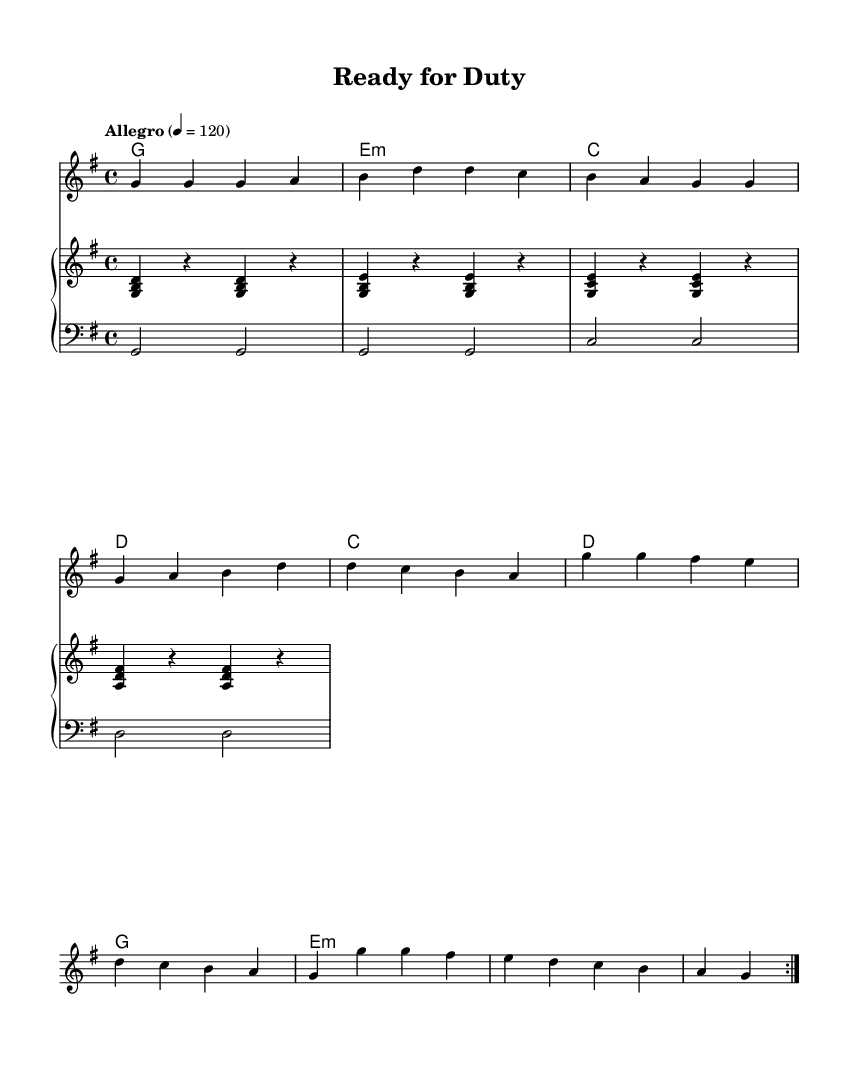What is the key signature of this music? The key signature indicates the music is in G major, which has one sharp (F#). This can be determined by looking at the key signature symbol, which shows one sharp at the top of the staff.
Answer: G major What is the time signature of this music? The time signature of the music is 4/4, which indicates there are four beats in each measure and a quarter note gets one beat. This can be found in the beginning of the staff.
Answer: 4/4 What is the tempo marking? The tempo marking is "Allegro," which signifies a lively and fast pace, typically around 120 beats per minute as indicated after the tempo text.
Answer: Allegro How many measures are in the repeated section? The repeated section has a total of 8 measures, as specified by the repeat volta, which indicates that the music should be played twice. Each iteration contains 4 measures, totaling 8.
Answer: 8 What chords are used in the progression? The chords used in the progression are G, E minor, C, and D, as listed in the chord names section beneath the staff. This chord progression is typical for R&B music, providing a rich harmonic background.
Answer: G, E minor, C, D What is the mood conveyed by the lyrics? The mood conveyed by the lyrics is one of determination and readiness, emphasizing strength and courage in facing challenges, common themes in R&B that can motivate listeners.
Answer: Determination How does the bass line complement the melody? The bass line complements the melody by providing a grounded foundation with root notes that align with the chords; this relationship emphasizes key moments in the melody and maintains rhythmic stability.
Answer: Grounded foundation 